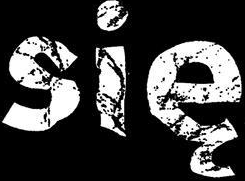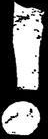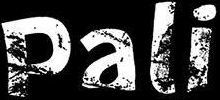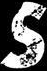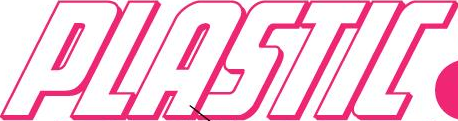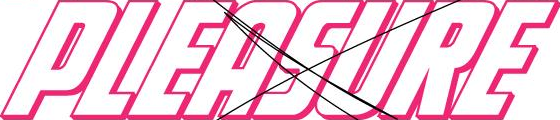Transcribe the words shown in these images in order, separated by a semicolon. się; !; Pali; s; PLASTIC; PLEASURE 